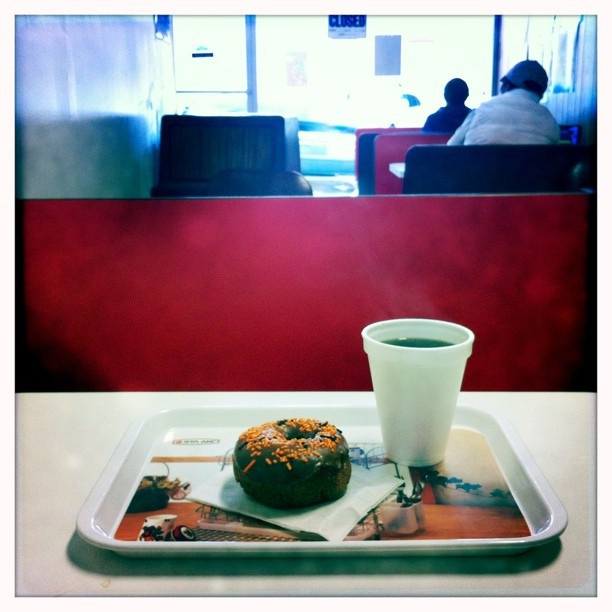Describe the objects in this image and their specific colors. I can see dining table in white, lightgray, darkgray, and darkgreen tones, cup in white, beige, darkgray, and lightgray tones, donut in white, black, brown, tan, and olive tones, chair in white, navy, black, darkblue, and blue tones, and people in white, darkgray, gray, navy, and lightblue tones in this image. 